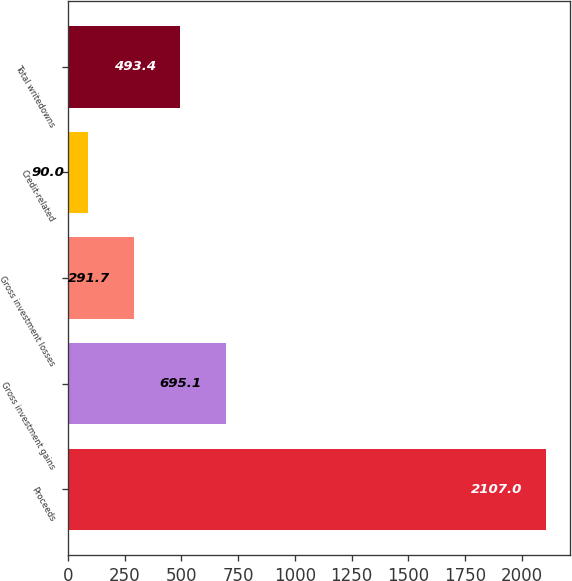Convert chart. <chart><loc_0><loc_0><loc_500><loc_500><bar_chart><fcel>Proceeds<fcel>Gross investment gains<fcel>Gross investment losses<fcel>Credit-related<fcel>Total writedowns<nl><fcel>2107<fcel>695.1<fcel>291.7<fcel>90<fcel>493.4<nl></chart> 